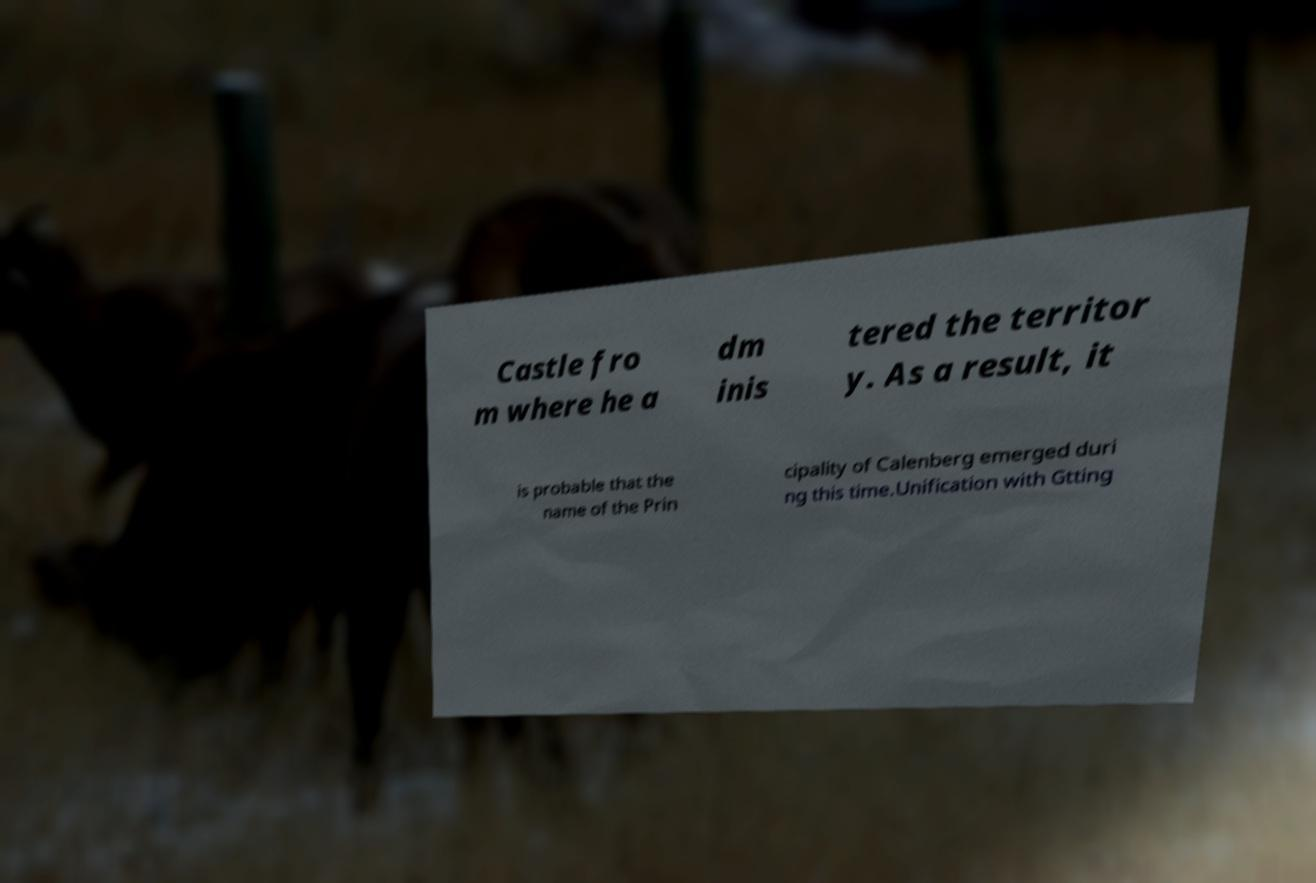Could you assist in decoding the text presented in this image and type it out clearly? Castle fro m where he a dm inis tered the territor y. As a result, it is probable that the name of the Prin cipality of Calenberg emerged duri ng this time.Unification with Gtting 